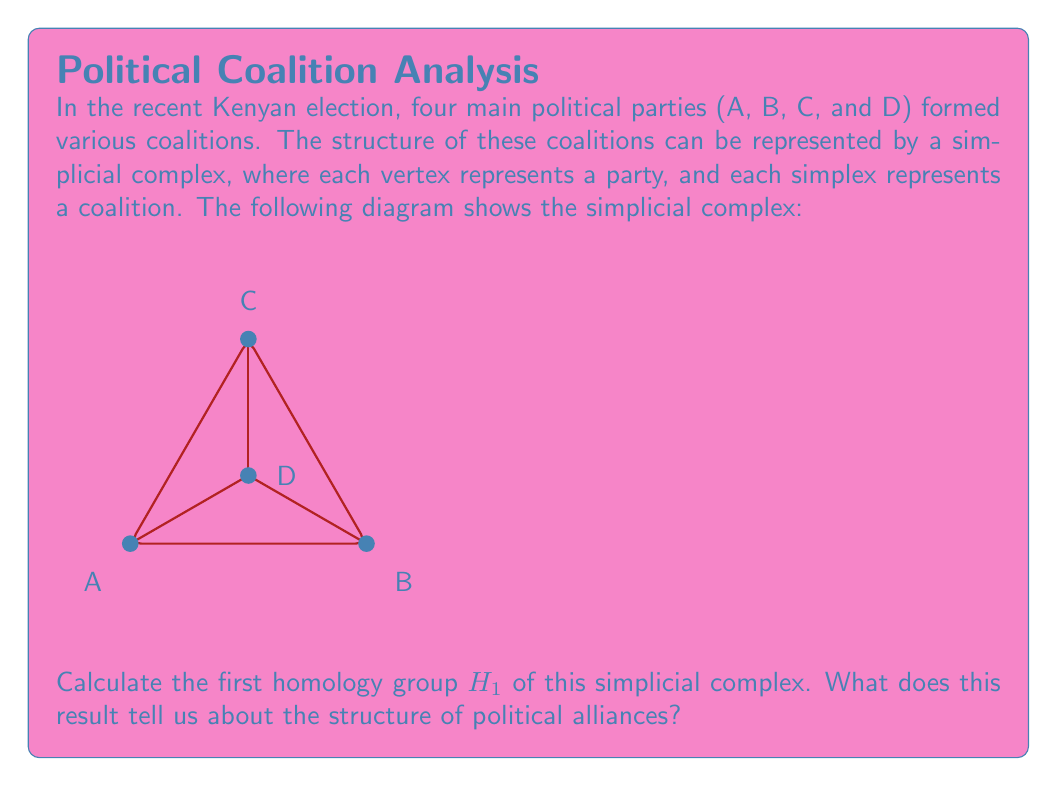Could you help me with this problem? To calculate the first homology group $H_1$, we need to follow these steps:

1) First, let's identify the simplices in each dimension:
   0-simplices: A, B, C, D
   1-simplices: AB, BC, CA, AD, BD, CD
   2-simplices: ABC

2) Now, let's calculate the chain groups:
   $C_0 = \mathbb{Z}^4$ (4 vertices)
   $C_1 = \mathbb{Z}^6$ (6 edges)
   $C_2 = \mathbb{Z}$ (1 triangle)

3) Next, we need to determine the boundary maps:
   $\partial_2: C_2 \to C_1$
   $\partial_1: C_1 \to C_0$

4) The boundary map $\partial_2$ maps the triangle ABC to its boundary:
   $\partial_2(ABC) = AB + BC - CA$

5) The boundary map $\partial_1$ maps each edge to the difference of its vertices:
   $\partial_1(AB) = B - A$, $\partial_1(BC) = C - B$, etc.

6) Now, we can calculate the kernel of $\partial_1$ (cycles) and the image of $\partial_2$ (boundaries):
   $ker(\partial_1) = \{aAB + bBC + cCA + dAD + eBD + fCD | a+b-c=0, d+e+f=0\}$
   $im(\partial_2) = \{a(AB + BC - CA) | a \in \mathbb{Z}\}$

7) The first homology group $H_1$ is defined as $ker(\partial_1) / im(\partial_2)$

8) After calculations, we find that $H_1 \cong \mathbb{Z}$

This result tells us that there is one non-trivial cycle in the political alliance structure that cannot be filled or broken. In the context of Kenyan politics, this suggests that there is one significant "loop" in the coalition structure that represents a stable or persistent pattern of alliances among the parties. The fact that $H_1$ is non-zero indicates that the coalition structure is not simply tree-like, but has some complexity to it.
Answer: $H_1 \cong \mathbb{Z}$ 